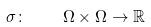Convert formula to latex. <formula><loc_0><loc_0><loc_500><loc_500>\sigma \colon \quad \Omega \times \Omega \rightarrow \mathbb { R }</formula> 